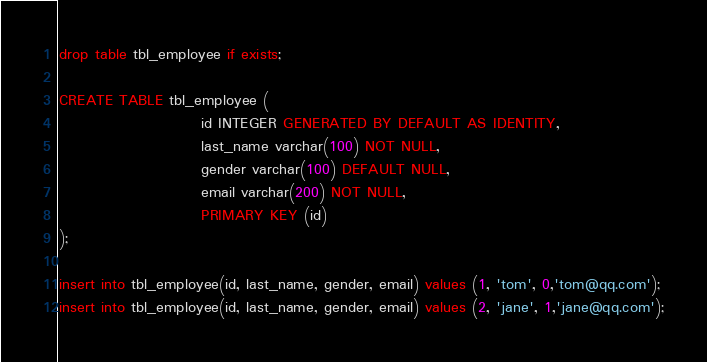<code> <loc_0><loc_0><loc_500><loc_500><_SQL_>

drop table tbl_employee if exists;

CREATE TABLE tbl_employee (
                        id INTEGER GENERATED BY DEFAULT AS IDENTITY,
                        last_name varchar(100) NOT NULL,
                        gender varchar(100) DEFAULT NULL,
                        email varchar(200) NOT NULL,
                        PRIMARY KEY (id)
);

insert into tbl_employee(id, last_name, gender, email) values (1, 'tom', 0,'tom@qq.com');
insert into tbl_employee(id, last_name, gender, email) values (2, 'jane', 1,'jane@qq.com');
</code> 